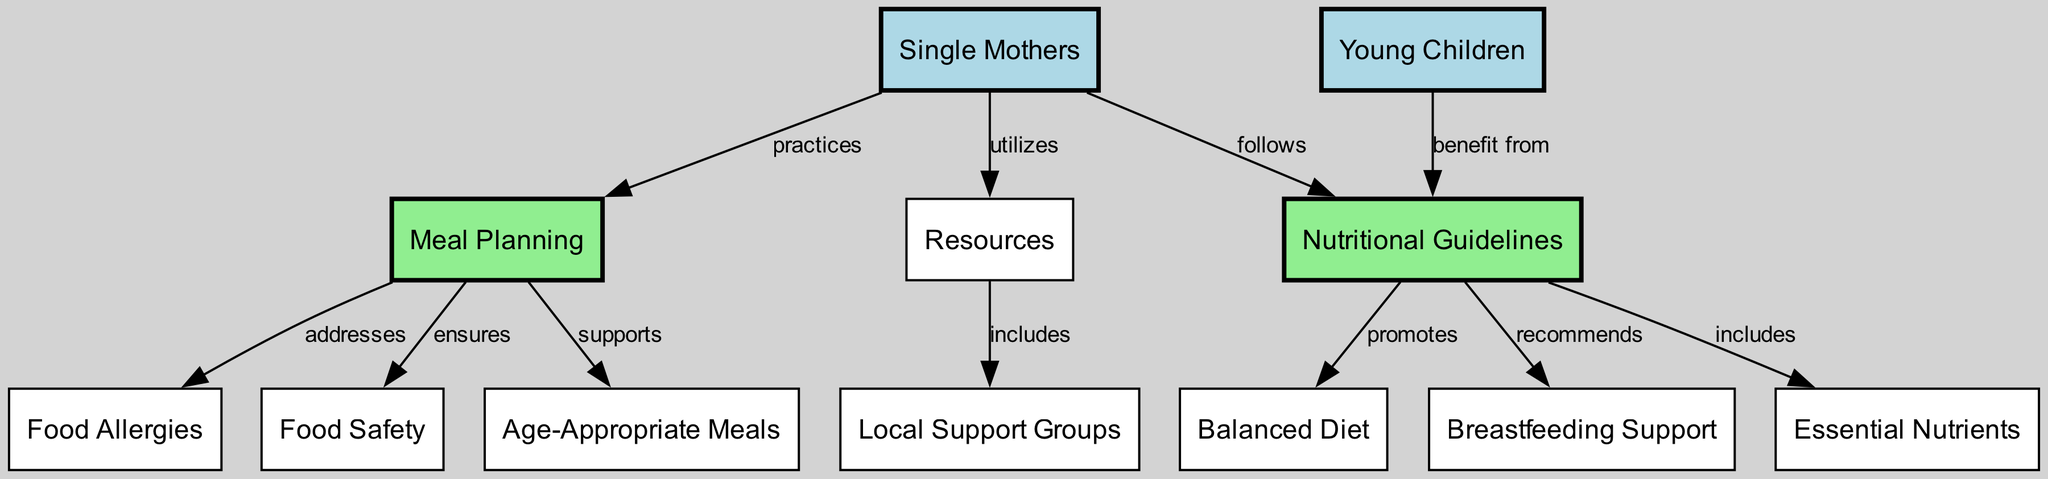What is the primary focus of the diagram? The diagram centers around the relationship between single mothers, young children, nutritional guidelines, and meal planning, showing how these elements interact to promote health and well-being.
Answer: Nutritional guidelines and meal planning How many nodes are represented in the diagram? By counting the listed nodes, we see there are 12 total nodes in the diagram, each representing different aspects of the focus area.
Answer: 12 What type of meals does meal planning support? According to the diagram, meal planning specifically supports the creation of age-appropriate meals for young children to meet their dietary needs.
Answer: Age-Appropriate Meals What is one resource utilized by single mothers? The diagram shows that single mothers utilize resources that can include local support groups, tools, and information related to meal planning and nutrition.
Answer: Resources How do nutritional guidelines benefit young children? The diagram indicates that young children benefit from nutritional guidelines by accessing recommendations for a balanced diet that promotes their growth and development.
Answer: Benefit from What is the connection between nutritional guidelines and essential nutrients? The nutritional guidelines include essential nutrients, which are key for the health and development of both single mothers and their young children, as indicated in the diagram.
Answer: Includes What do nutritional guidelines recommend regarding breastfeeding? The diagram states that nutritional guidelines specifically recommend breastfeeding support for single mothers to ensure optimal nourishment for infants.
Answer: Breastfeeding Support Which aspect does meal planning ensure for single mothers? The diagram illustrates that meal planning ensures food safety, which is crucial for both single mothers and their children to avoid health risks associated with improper food handling.
Answer: Food Safety What do local support groups provide? The diagram indicates that local support groups are included in the resources available to single mothers, which can provide community and assistance in meal planning and nutritional support.
Answer: Local Support Groups 